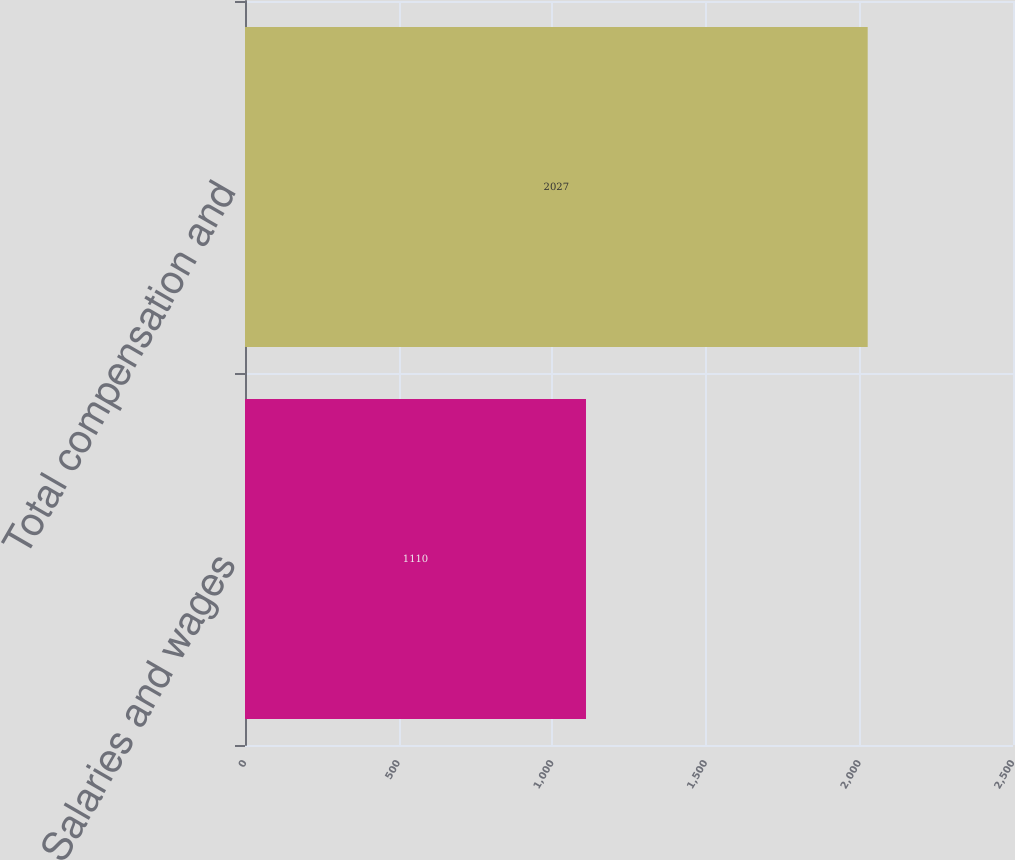Convert chart. <chart><loc_0><loc_0><loc_500><loc_500><bar_chart><fcel>Salaries and wages<fcel>Total compensation and<nl><fcel>1110<fcel>2027<nl></chart> 